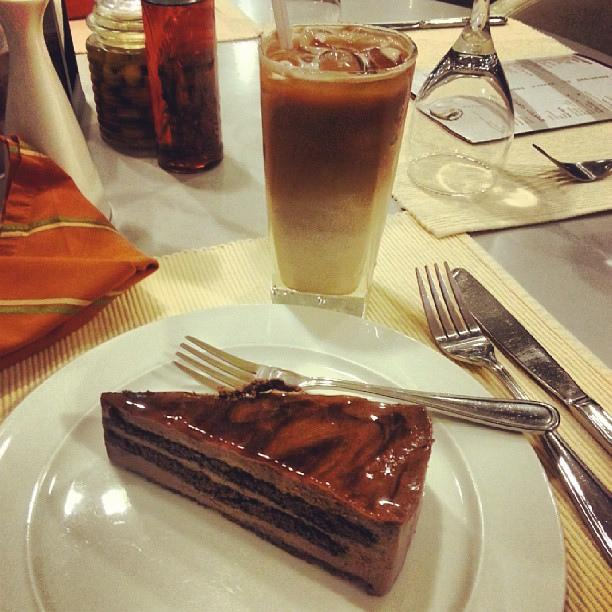What are they expecting to be poured into the upside down glass? wine 